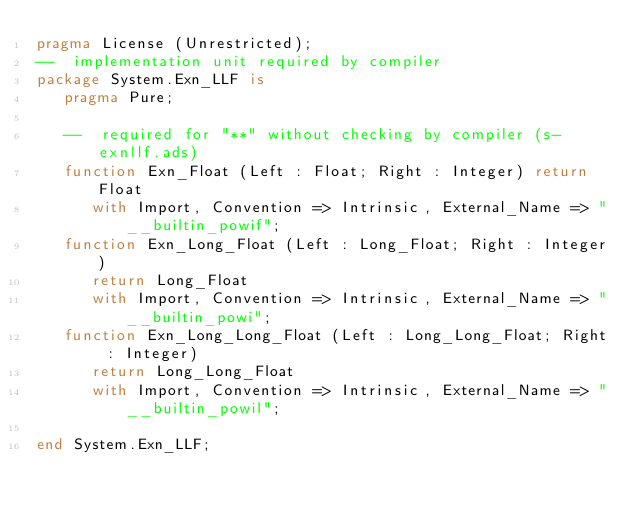Convert code to text. <code><loc_0><loc_0><loc_500><loc_500><_Ada_>pragma License (Unrestricted);
--  implementation unit required by compiler
package System.Exn_LLF is
   pragma Pure;

   --  required for "**" without checking by compiler (s-exnllf.ads)
   function Exn_Float (Left : Float; Right : Integer) return Float
      with Import, Convention => Intrinsic, External_Name => "__builtin_powif";
   function Exn_Long_Float (Left : Long_Float; Right : Integer)
      return Long_Float
      with Import, Convention => Intrinsic, External_Name => "__builtin_powi";
   function Exn_Long_Long_Float (Left : Long_Long_Float; Right : Integer)
      return Long_Long_Float
      with Import, Convention => Intrinsic, External_Name => "__builtin_powil";

end System.Exn_LLF;
</code> 